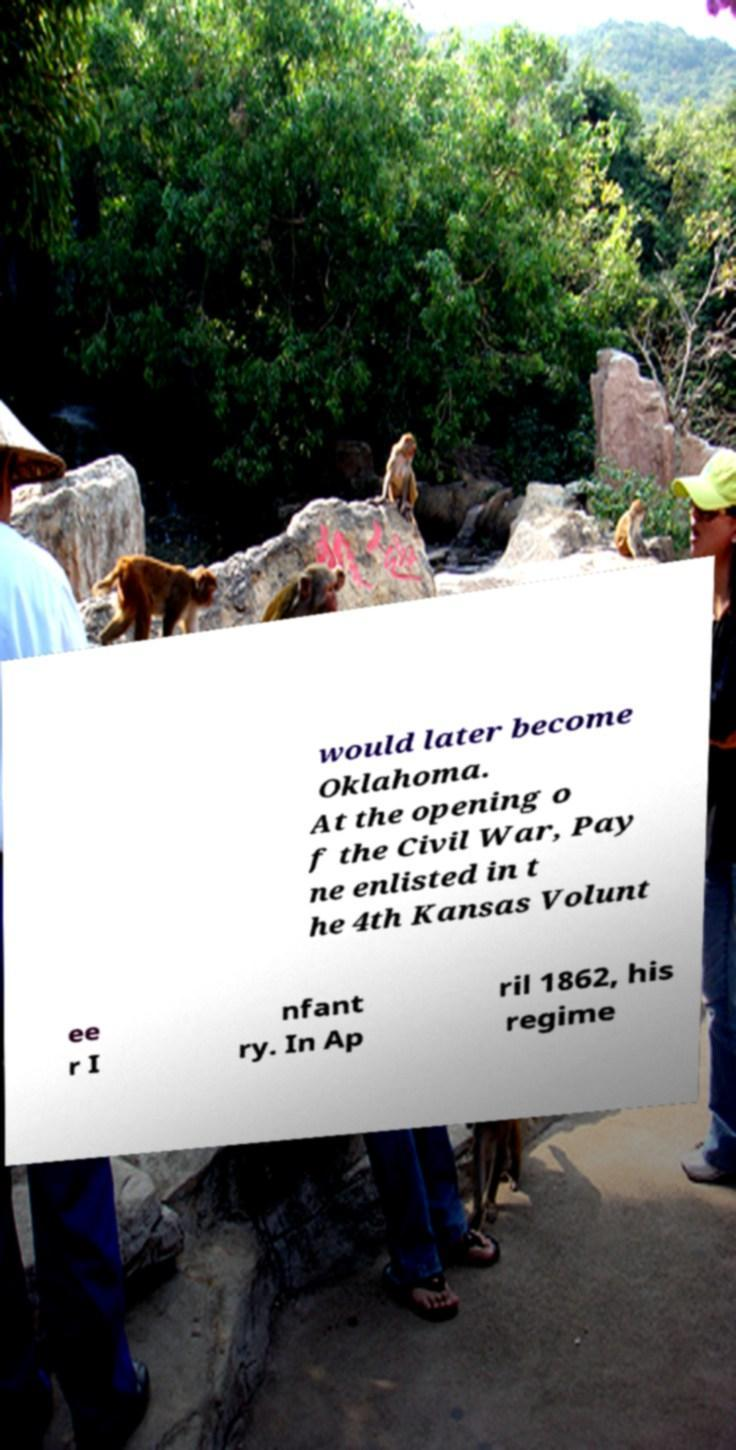Can you read and provide the text displayed in the image?This photo seems to have some interesting text. Can you extract and type it out for me? would later become Oklahoma. At the opening o f the Civil War, Pay ne enlisted in t he 4th Kansas Volunt ee r I nfant ry. In Ap ril 1862, his regime 